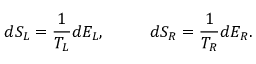Convert formula to latex. <formula><loc_0><loc_0><loc_500><loc_500>d S _ { L } = { \frac { 1 } { T _ { L } } } d E _ { L } , \quad d S _ { R } = { \frac { 1 } { T _ { R } } } d E _ { R } .</formula> 